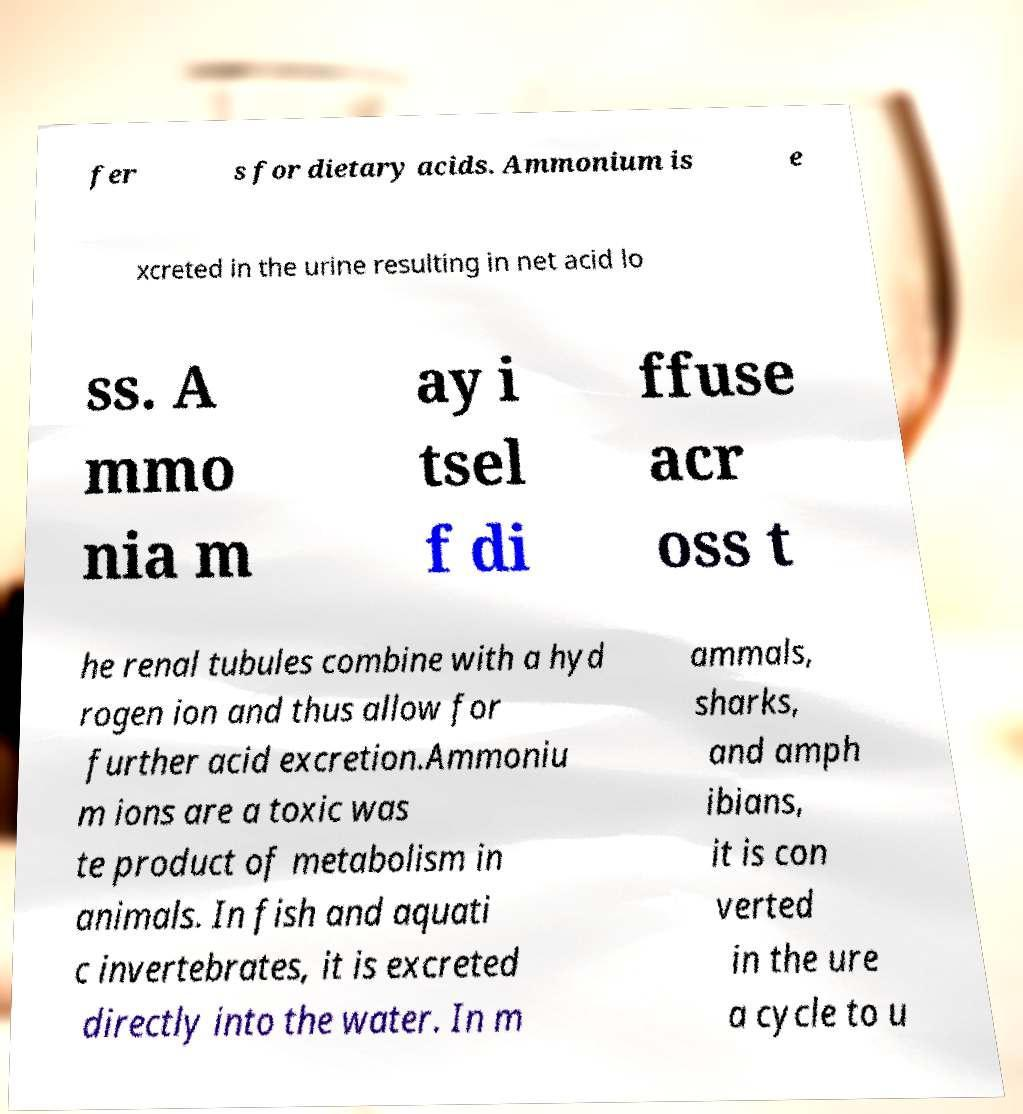Could you assist in decoding the text presented in this image and type it out clearly? fer s for dietary acids. Ammonium is e xcreted in the urine resulting in net acid lo ss. A mmo nia m ay i tsel f di ffuse acr oss t he renal tubules combine with a hyd rogen ion and thus allow for further acid excretion.Ammoniu m ions are a toxic was te product of metabolism in animals. In fish and aquati c invertebrates, it is excreted directly into the water. In m ammals, sharks, and amph ibians, it is con verted in the ure a cycle to u 